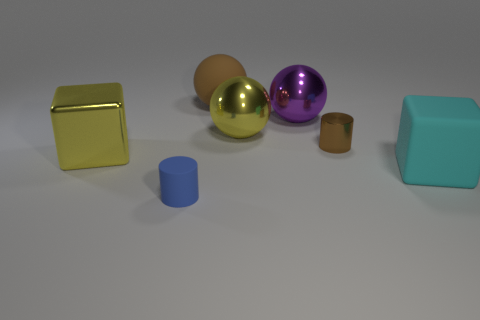The shiny object that is the same color as the large rubber ball is what size?
Give a very brief answer. Small. Does the tiny cylinder right of the large yellow sphere have the same material as the tiny cylinder that is left of the tiny metal thing?
Make the answer very short. No. There is a ball that is the same color as the tiny shiny object; what is its material?
Give a very brief answer. Rubber. What number of other small objects are the same shape as the brown rubber object?
Your answer should be compact. 0. Is the number of brown shiny things left of the small brown shiny cylinder greater than the number of purple cylinders?
Your response must be concise. No. The large rubber thing that is right of the yellow metal thing right of the block to the left of the brown ball is what shape?
Offer a very short reply. Cube. Is the shape of the brown thing in front of the big purple sphere the same as the brown thing left of the purple thing?
Provide a short and direct response. No. Is there any other thing that is the same size as the shiny block?
Provide a succinct answer. Yes. How many cylinders are purple objects or small brown objects?
Give a very brief answer. 1. Are the tiny brown thing and the big yellow block made of the same material?
Keep it short and to the point. Yes. 